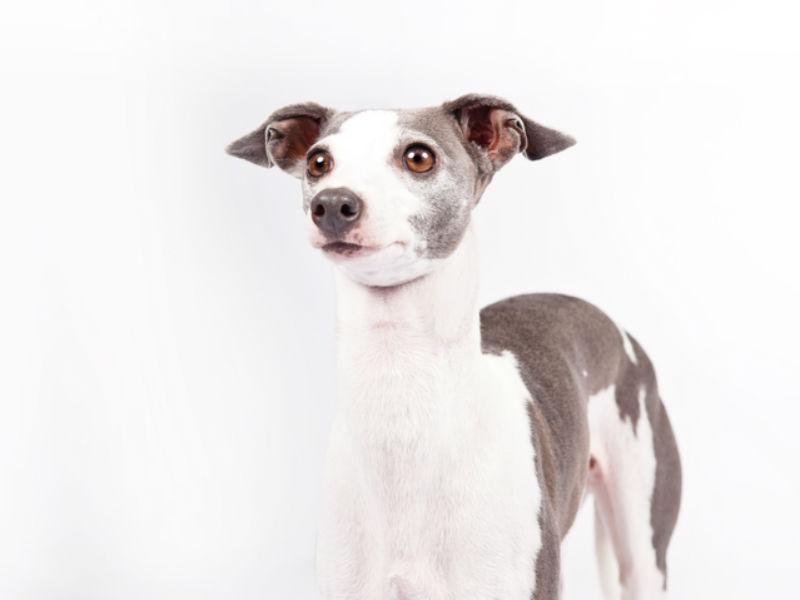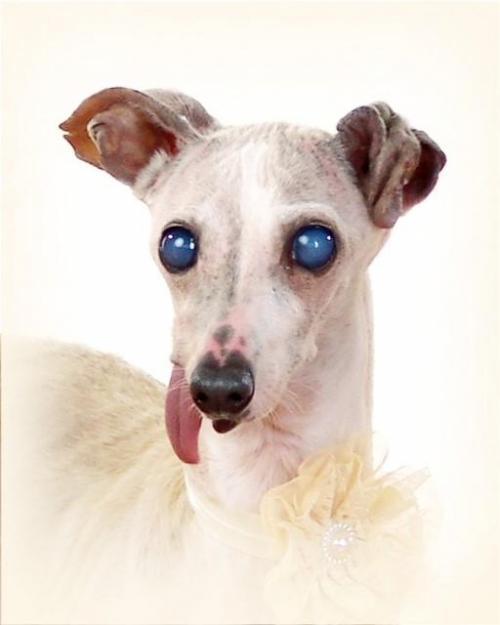The first image is the image on the left, the second image is the image on the right. Examine the images to the left and right. Is the description "An image shows a dog with its tongue sticking out." accurate? Answer yes or no. Yes. 